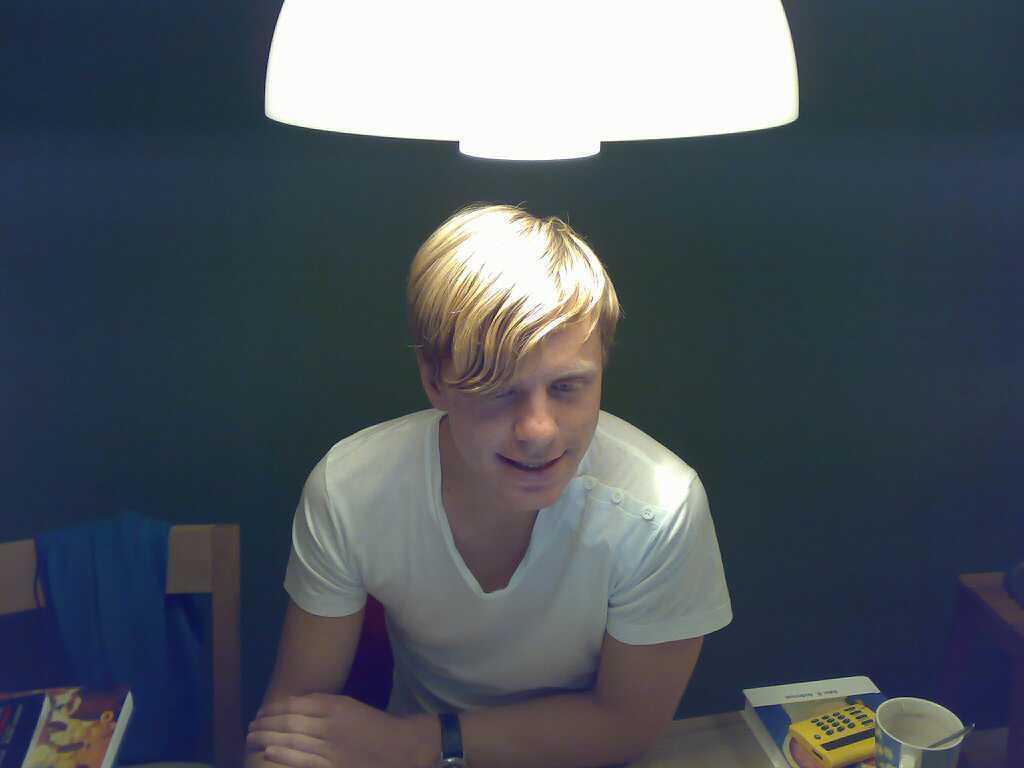Please provide a concise description of this image. In the picture I can see a man in the middle of the image. He is wearing a white color T-shirt and there is a smile on his face. I can see a wooden chair on the bottom left side. I can see a book, a telephone and a cup are kept on the table. There is a lamp at the top of the image. 